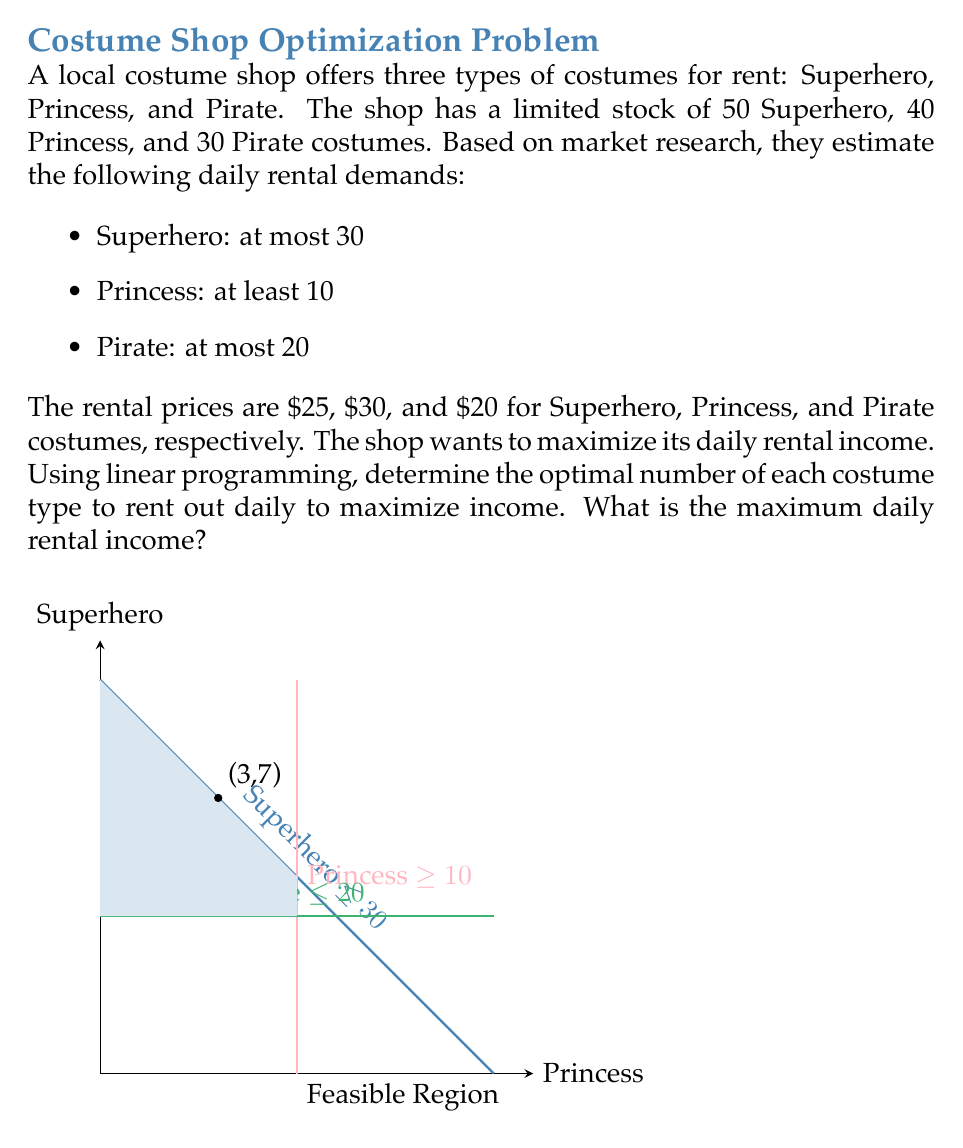Can you solve this math problem? Let's solve this step-by-step using linear programming:

1) Define variables:
   $x$ = number of Superhero costumes
   $y$ = number of Princess costumes
   $z$ = number of Pirate costumes

2) Objective function (to maximize):
   $P = 25x + 30y + 20z$

3) Constraints:
   $x + y + z \leq 120$ (total costumes available)
   $x \leq 50$ (Superhero stock)
   $y \leq 40$ (Princess stock)
   $z \leq 30$ (Pirate stock)
   $x \leq 30$ (Superhero demand)
   $y \geq 10$ (Princess demand)
   $z \leq 20$ (Pirate demand)
   $x, y, z \geq 0$ (non-negativity)

4) Solving graphically or using the simplex method, we find the optimal solution at the corner point:
   $x = 30$ (Superhero)
   $y = 10$ (Princess)
   $z = 20$ (Pirate)

5) Calculate the maximum daily rental income:
   $P = 25(30) + 30(10) + 20(20)$
   $P = 750 + 300 + 400 = 1450$

Therefore, the optimal strategy is to rent out 30 Superhero, 10 Princess, and 20 Pirate costumes daily, resulting in a maximum daily rental income of $1450.
Answer: $1450 